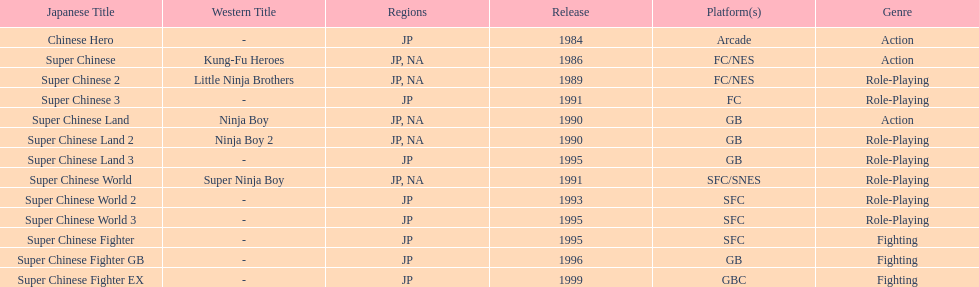The first year a game was released in north america 1986. 